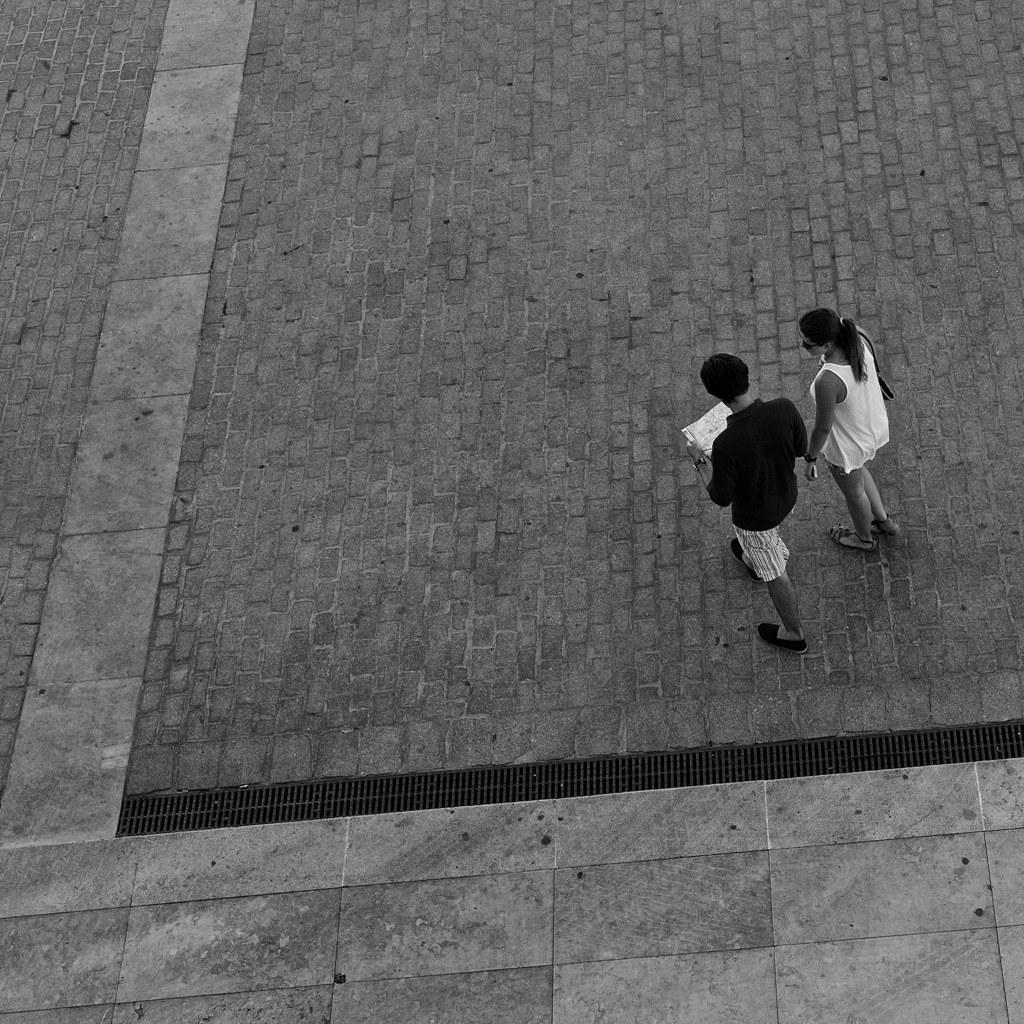How many people are in the image? There are two people in the image. What are the people doing in the image? The two people are walking. On what surface are the people walking? The people are walking on the floor. What type of cake is being protested by the people in the image? There is no cake or protest present in the image; it features two people walking on the floor. 